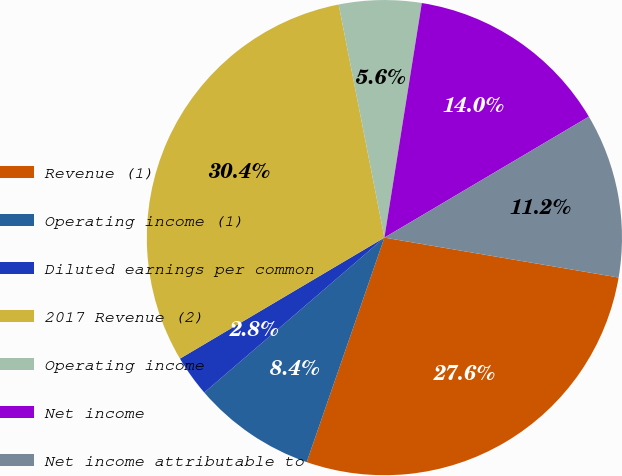Convert chart to OTSL. <chart><loc_0><loc_0><loc_500><loc_500><pie_chart><fcel>Revenue (1)<fcel>Operating income (1)<fcel>Diluted earnings per common<fcel>2017 Revenue (2)<fcel>Operating income<fcel>Net income<fcel>Net income attributable to<nl><fcel>27.62%<fcel>8.39%<fcel>2.8%<fcel>30.42%<fcel>5.6%<fcel>13.98%<fcel>11.19%<nl></chart> 